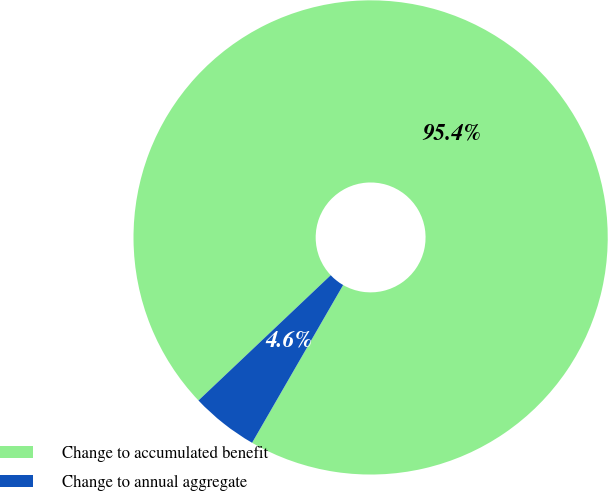<chart> <loc_0><loc_0><loc_500><loc_500><pie_chart><fcel>Change to accumulated benefit<fcel>Change to annual aggregate<nl><fcel>95.4%<fcel>4.6%<nl></chart> 